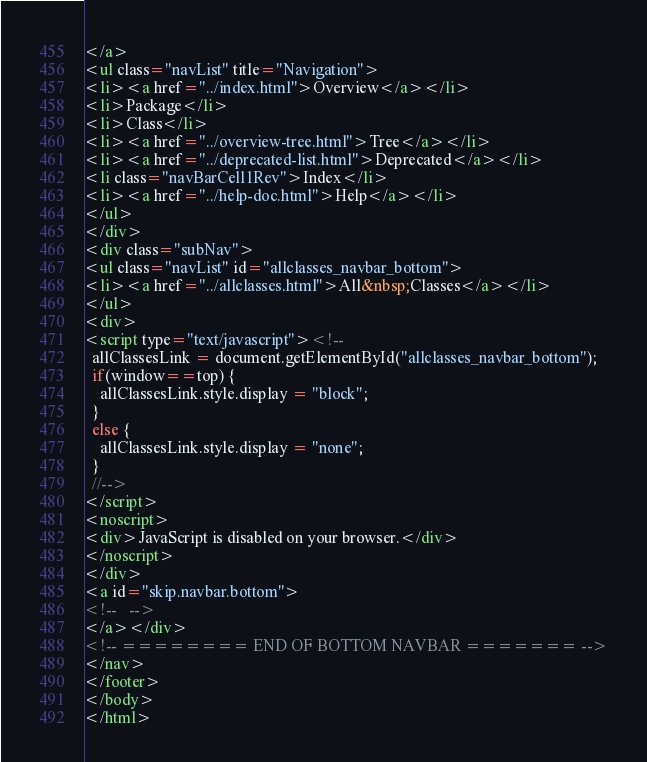<code> <loc_0><loc_0><loc_500><loc_500><_HTML_></a>
<ul class="navList" title="Navigation">
<li><a href="../index.html">Overview</a></li>
<li>Package</li>
<li>Class</li>
<li><a href="../overview-tree.html">Tree</a></li>
<li><a href="../deprecated-list.html">Deprecated</a></li>
<li class="navBarCell1Rev">Index</li>
<li><a href="../help-doc.html">Help</a></li>
</ul>
</div>
<div class="subNav">
<ul class="navList" id="allclasses_navbar_bottom">
<li><a href="../allclasses.html">All&nbsp;Classes</a></li>
</ul>
<div>
<script type="text/javascript"><!--
  allClassesLink = document.getElementById("allclasses_navbar_bottom");
  if(window==top) {
    allClassesLink.style.display = "block";
  }
  else {
    allClassesLink.style.display = "none";
  }
  //-->
</script>
<noscript>
<div>JavaScript is disabled on your browser.</div>
</noscript>
</div>
<a id="skip.navbar.bottom">
<!--   -->
</a></div>
<!-- ======== END OF BOTTOM NAVBAR ======= -->
</nav>
</footer>
</body>
</html>
</code> 